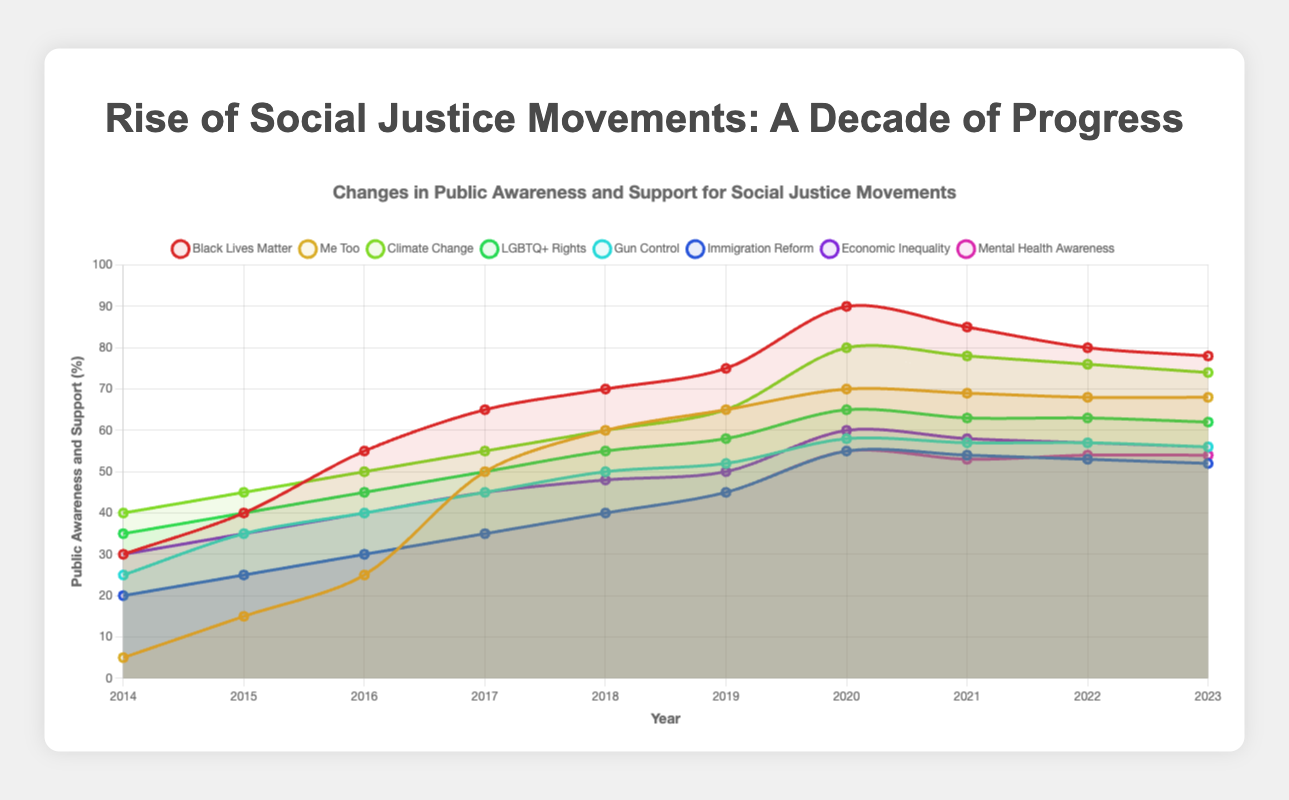Which social justice movement saw the highest public awareness increase between 2014 and 2023? To find out which social justice movement saw the highest increase, subtract the percentage in 2014 from the percentage in 2023 for each movement and compare the differences. Black Lives Matter: 78 - 30 = 48, Me Too: 68 - 5 = 63, Climate Change: 74 - 40 = 34, LGBTQ+ Rights: 62 - 35 = 27, Gun Control: 56 - 25 = 31, Immigration Reform: 52 - 20 = 32, Economic Inequality: 56 - 30 = 26, Mental Health Awareness: 54 - 20 = 34. The Me Too movement had the highest increase of 63%.
Answer: Me Too Which movement had the lowest public awareness in 2014? Examine the starting point for each movement in 2014: Black Lives Matter: 30, Me Too: 5, Climate Change: 40, LGBTQ+ Rights: 35, Gun Control: 25, Immigration Reform: 20, Economic Inequality: 30, Mental Health Awareness: 20. Me Too has the lowest starting awareness at 5%.
Answer: Me Too Between 2015 and 2023, which two movements had the smallest change in public awareness? Calculate the difference in awareness for each movement between 2015 and 2023. Black Lives Matter: 78 - 40 = 38, Me Too: 68 - 15 = 53, Climate Change: 74 - 45 = 29, LGBTQ+ Rights: 62 - 40 = 22, Gun Control: 56 - 35 = 21, Immigration Reform: 52 - 25 = 27, Economic Inequality: 56 - 35 = 21, Mental Health Awareness: 54 - 25 = 29. The two movements with the smallest changes are Gun Control and Economic Inequality, both with a change of 21%.
Answer: Gun Control and Economic Inequality In which year did public awareness for the Me Too movement surpass that of Immigration Reform? Compare the awareness percentages year by year. In 2014, Me Too: 5, Immigration Reform: 20. In 2015, Me Too: 15, Immigration Reform: 25. In 2016, Me Too: 25, Immigration Reform: 30. In 2017, Me Too: 50, Immigration Reform: 35. The Me Too movement surpasses Immigration Reform in 2017, as 50 > 35.
Answer: 2017 Which movement had the highest public awareness in 2020, and what was the percentage? Refer to the data points for each movement in 2020. Black Lives Matter: 90, Me Too: 70, Climate Change: 80, LGBTQ+ Rights: 65, Gun Control: 58, Immigration Reform: 55, Economic Inequality: 60, Mental Health Awareness: 55. Black Lives Matter had the highest public awareness at 90%.
Answer: Black Lives Matter with 90% What was the average public awareness for Climate Change over the decade? To find the average, add the percentages for each year and divide by the number of years: (40 + 45 + 50 + 55 + 60 + 65 + 80 + 78 + 76 + 74). This sums up to 623. Dividing 623 by 10 gives an average of 62.3.
Answer: 62.3 Which two movements had exactly the same public awareness percentage in 2022, and what was the percentage? Compare the 2022 data points. Black Lives Matter: 80, Me Too: 68, Climate Change: 76, LGBTQ+ Rights: 63, Gun Control: 57, Immigration Reform: 53, Economic Inequality: 57, Mental Health Awareness: 54. Gun Control and Economic Inequality both have 57%.
Answer: Gun Control and Economic Inequality with 57% In which year did the public awareness for LGBTQ+ Rights peak, and what was the value? Determine the highest value in the LGBTQ+ Rights data. The highest values are in 2020 and 2021, both at 65.
Answer: 2020 and 2021 with 65% 